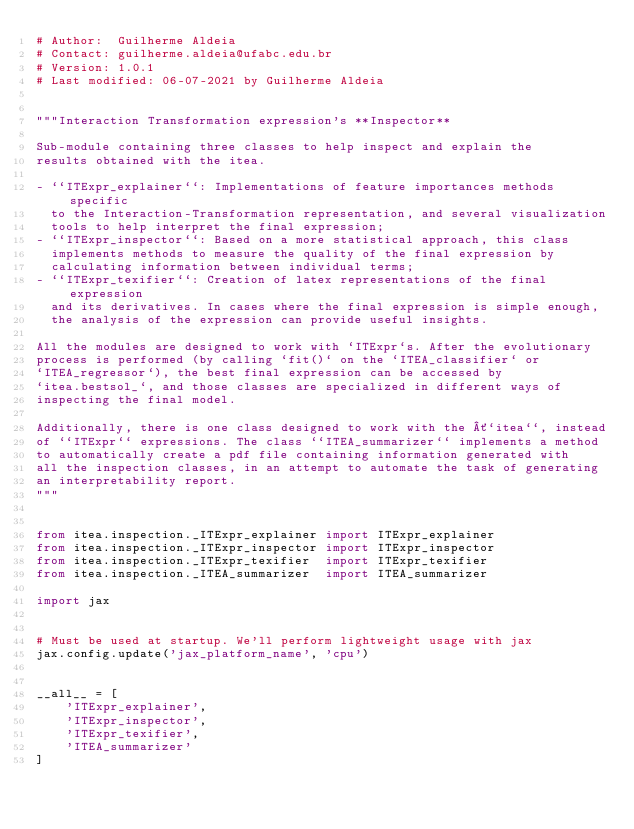Convert code to text. <code><loc_0><loc_0><loc_500><loc_500><_Python_># Author:  Guilherme Aldeia
# Contact: guilherme.aldeia@ufabc.edu.br
# Version: 1.0.1
# Last modified: 06-07-2021 by Guilherme Aldeia


"""Interaction Transformation expression's **Inspector**

Sub-module containing three classes to help inspect and explain the
results obtained with the itea.

- ``ITExpr_explainer``: Implementations of feature importances methods specific
  to the Interaction-Transformation representation, and several visualization
  tools to help interpret the final expression;
- ``ITExpr_inspector``: Based on a more statistical approach, this class 
  implements methods to measure the quality of the final expression by
  calculating information between individual terms;
- ``ITExpr_texifier``: Creation of latex representations of the final expression
  and its derivatives. In cases where the final expression is simple enough,
  the analysis of the expression can provide useful insights.

All the modules are designed to work with `ITExpr`s. After the evolutionary
process is performed (by calling `fit()` on the `ITEA_classifier` or
`ITEA_regressor`), the best final expression can be accessed by
`itea.bestsol_`, and those classes are specialized in different ways of
inspecting the final model.

Additionally, there is one class designed to work with the ´`itea``, instead
of ``ITExpr`` expressions. The class ``ITEA_summarizer`` implements a method
to automatically create a pdf file containing information generated with 
all the inspection classes, in an attempt to automate the task of generating
an interpretability report. 
"""


from itea.inspection._ITExpr_explainer import ITExpr_explainer
from itea.inspection._ITExpr_inspector import ITExpr_inspector
from itea.inspection._ITExpr_texifier  import ITExpr_texifier
from itea.inspection._ITEA_summarizer  import ITEA_summarizer

import jax


# Must be used at startup. We'll perform lightweight usage with jax 
jax.config.update('jax_platform_name', 'cpu')


__all__ = [
    'ITExpr_explainer',
    'ITExpr_inspector',
    'ITExpr_texifier',
    'ITEA_summarizer'
]</code> 